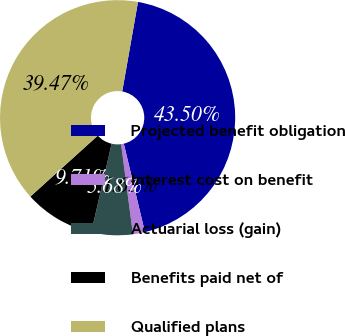Convert chart to OTSL. <chart><loc_0><loc_0><loc_500><loc_500><pie_chart><fcel>Projected benefit obligation<fcel>Interest cost on benefit<fcel>Actuarial loss (gain)<fcel>Benefits paid net of<fcel>Qualified plans<nl><fcel>43.5%<fcel>1.65%<fcel>5.68%<fcel>9.71%<fcel>39.47%<nl></chart> 